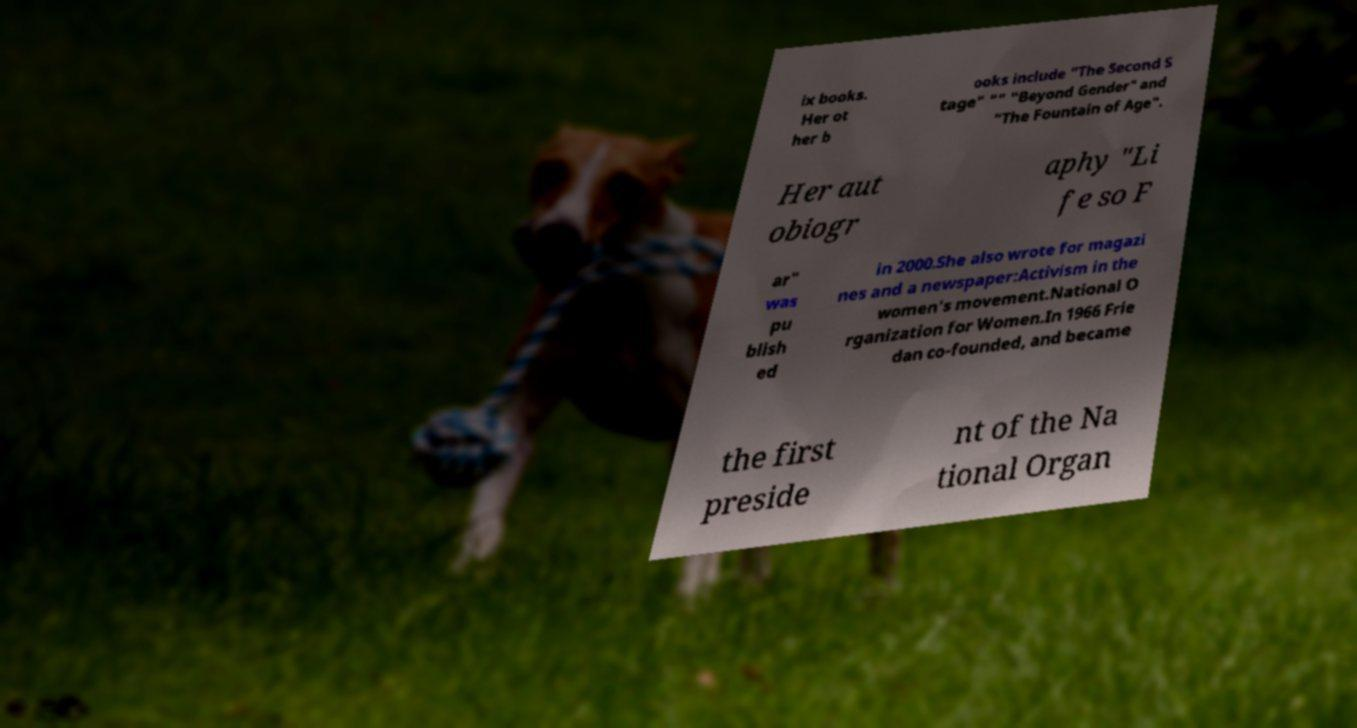Please read and relay the text visible in this image. What does it say? ix books. Her ot her b ooks include "The Second S tage" "" "Beyond Gender" and "The Fountain of Age". Her aut obiogr aphy "Li fe so F ar" was pu blish ed in 2000.She also wrote for magazi nes and a newspaper:Activism in the women's movement.National O rganization for Women.In 1966 Frie dan co-founded, and became the first preside nt of the Na tional Organ 